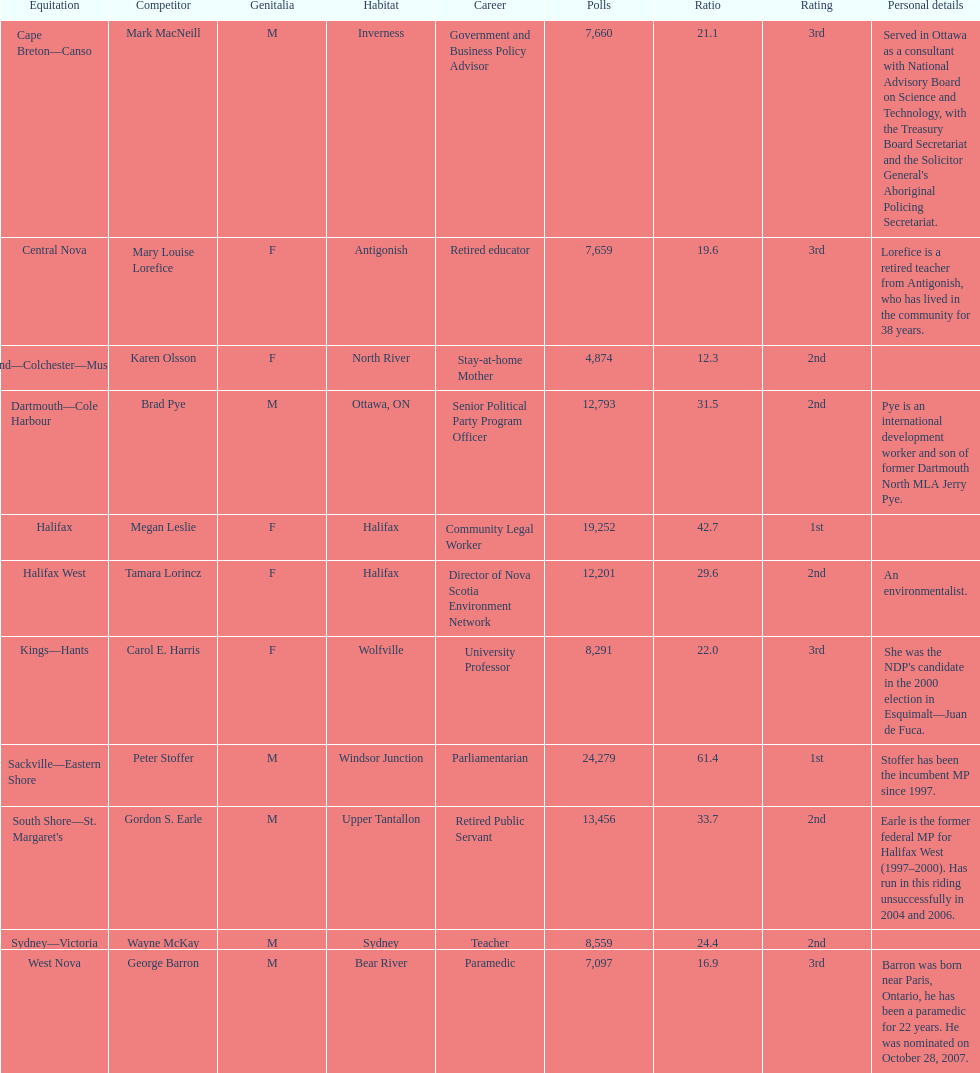Tell me the total number of votes the female candidates got. 52,277. 